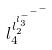<formula> <loc_0><loc_0><loc_500><loc_500>l _ { 4 } ^ { l _ { 2 } ^ { l _ { 3 } ^ { - ^ { - ^ { - } } } } }</formula> 